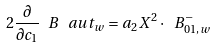Convert formula to latex. <formula><loc_0><loc_0><loc_500><loc_500>2 \frac { \partial } { \partial c _ { 1 } } \ B ^ { \ } a u t _ { w } = a _ { 2 } X ^ { 2 } \cdot \ B ^ { - } _ { 0 1 , w }</formula> 